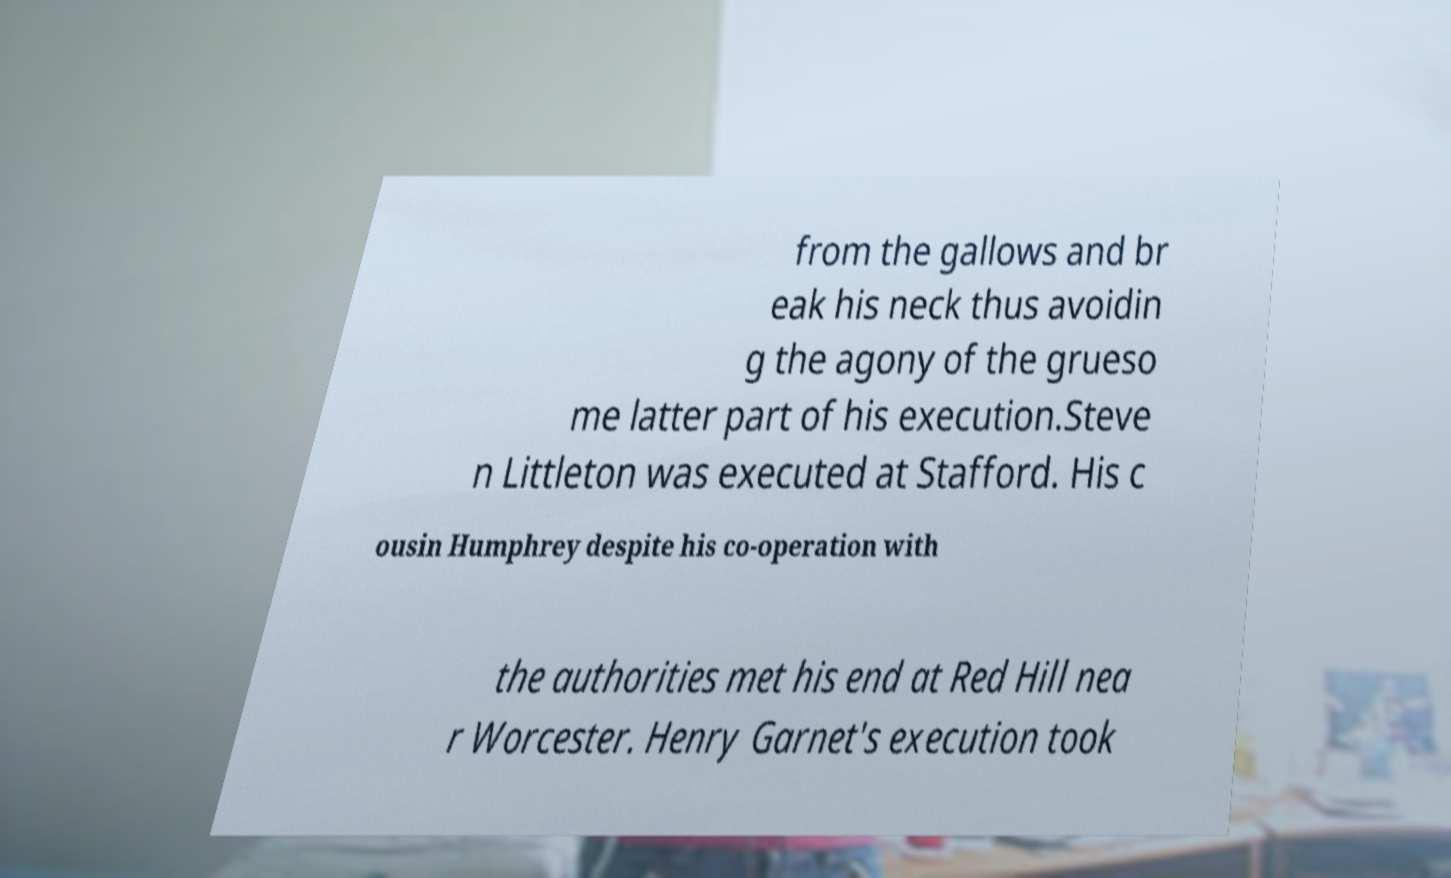Could you extract and type out the text from this image? from the gallows and br eak his neck thus avoidin g the agony of the grueso me latter part of his execution.Steve n Littleton was executed at Stafford. His c ousin Humphrey despite his co-operation with the authorities met his end at Red Hill nea r Worcester. Henry Garnet's execution took 